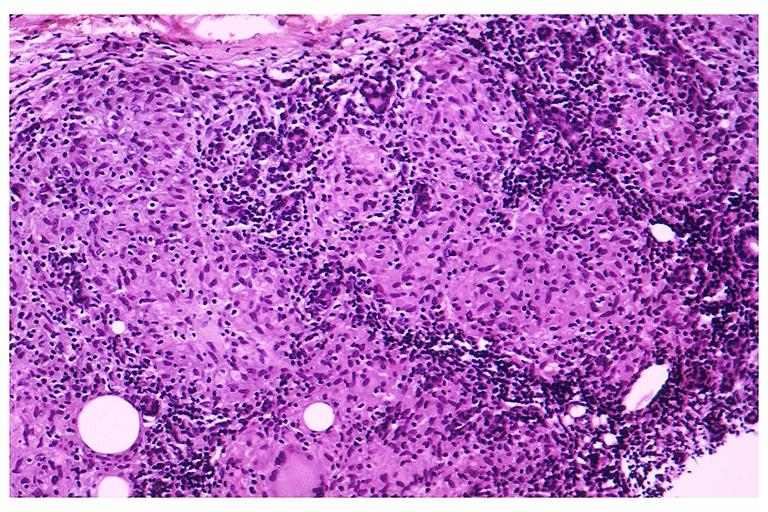does ulcerative lesion show sarcoidosis?
Answer the question using a single word or phrase. No 